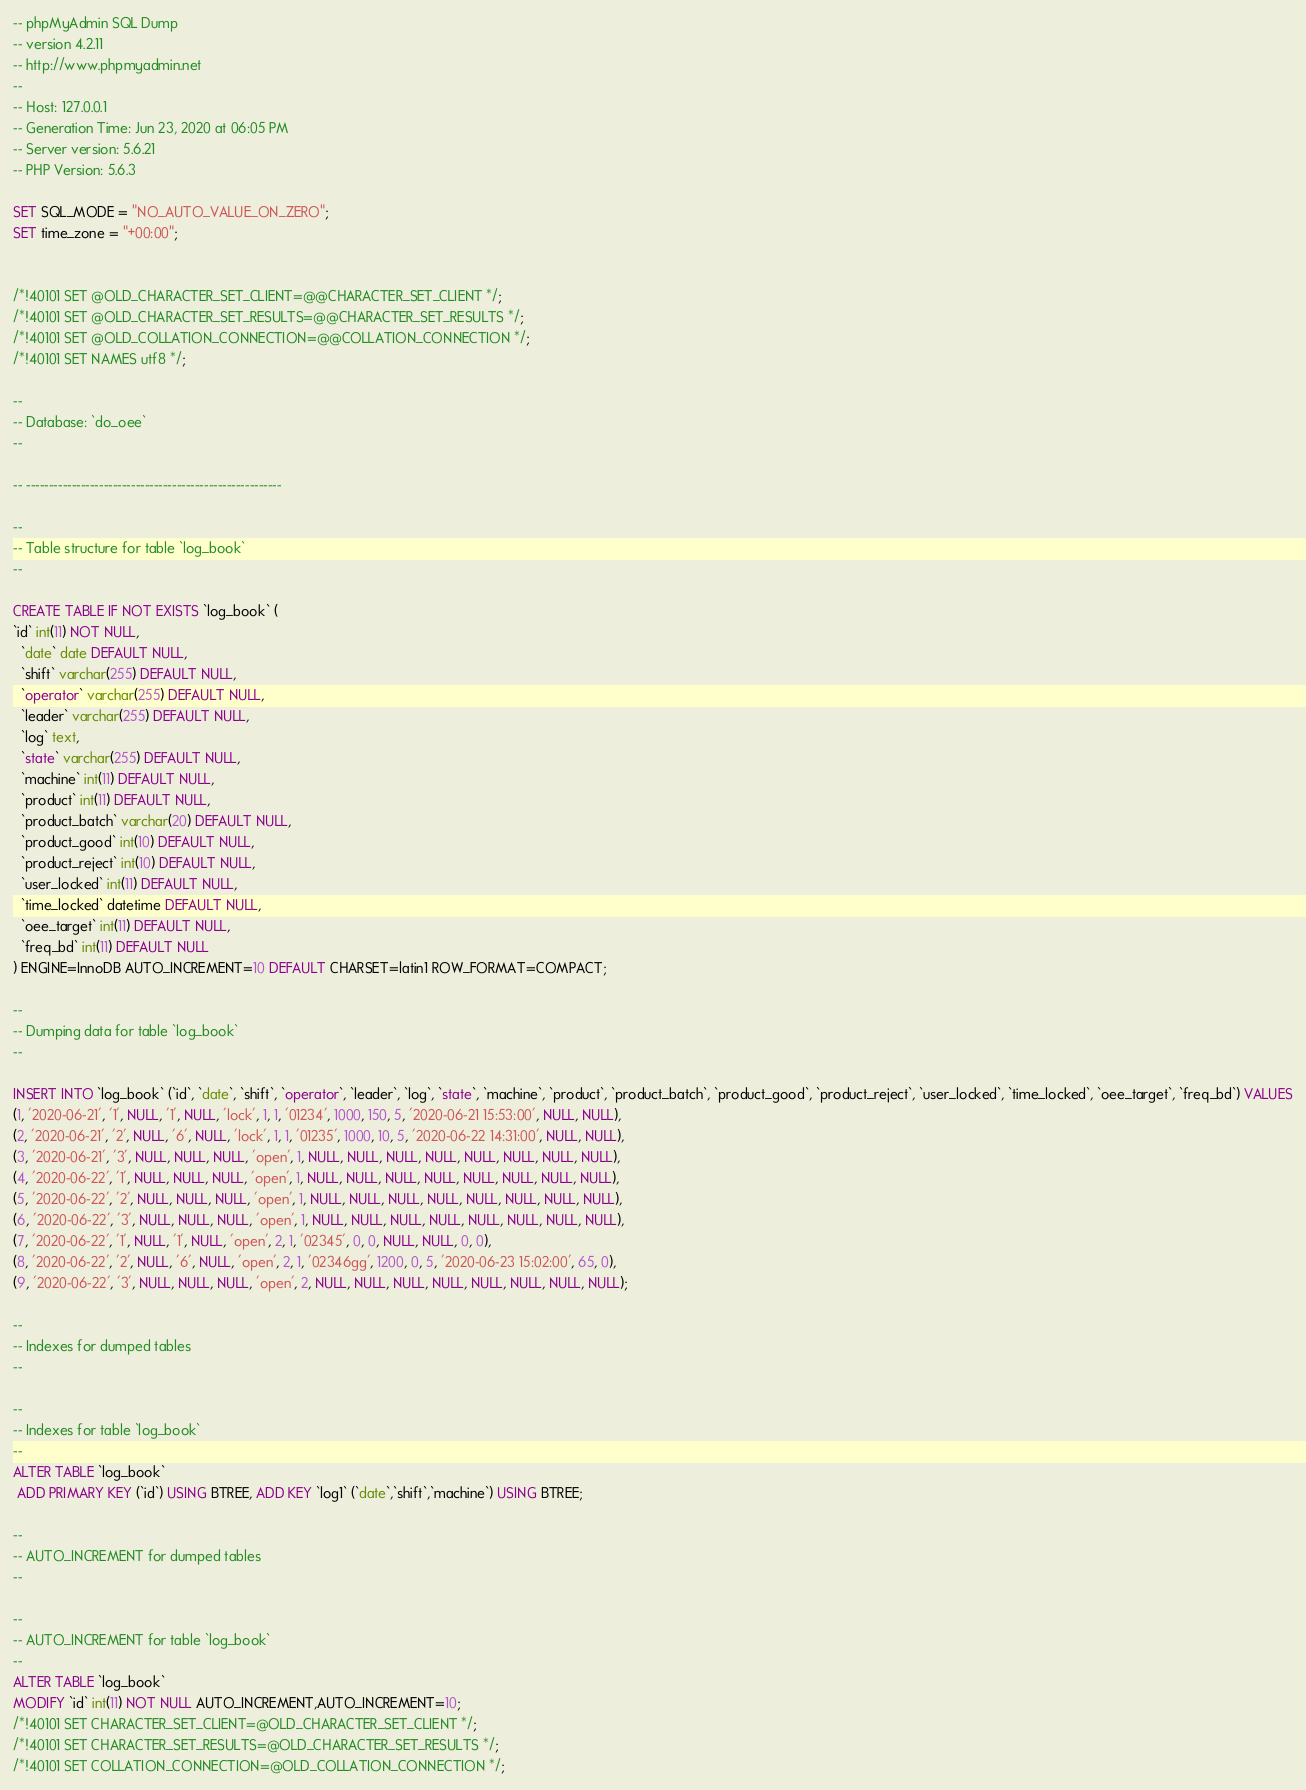Convert code to text. <code><loc_0><loc_0><loc_500><loc_500><_SQL_>-- phpMyAdmin SQL Dump
-- version 4.2.11
-- http://www.phpmyadmin.net
--
-- Host: 127.0.0.1
-- Generation Time: Jun 23, 2020 at 06:05 PM
-- Server version: 5.6.21
-- PHP Version: 5.6.3

SET SQL_MODE = "NO_AUTO_VALUE_ON_ZERO";
SET time_zone = "+00:00";


/*!40101 SET @OLD_CHARACTER_SET_CLIENT=@@CHARACTER_SET_CLIENT */;
/*!40101 SET @OLD_CHARACTER_SET_RESULTS=@@CHARACTER_SET_RESULTS */;
/*!40101 SET @OLD_COLLATION_CONNECTION=@@COLLATION_CONNECTION */;
/*!40101 SET NAMES utf8 */;

--
-- Database: `do_oee`
--

-- --------------------------------------------------------

--
-- Table structure for table `log_book`
--

CREATE TABLE IF NOT EXISTS `log_book` (
`id` int(11) NOT NULL,
  `date` date DEFAULT NULL,
  `shift` varchar(255) DEFAULT NULL,
  `operator` varchar(255) DEFAULT NULL,
  `leader` varchar(255) DEFAULT NULL,
  `log` text,
  `state` varchar(255) DEFAULT NULL,
  `machine` int(11) DEFAULT NULL,
  `product` int(11) DEFAULT NULL,
  `product_batch` varchar(20) DEFAULT NULL,
  `product_good` int(10) DEFAULT NULL,
  `product_reject` int(10) DEFAULT NULL,
  `user_locked` int(11) DEFAULT NULL,
  `time_locked` datetime DEFAULT NULL,
  `oee_target` int(11) DEFAULT NULL,
  `freq_bd` int(11) DEFAULT NULL
) ENGINE=InnoDB AUTO_INCREMENT=10 DEFAULT CHARSET=latin1 ROW_FORMAT=COMPACT;

--
-- Dumping data for table `log_book`
--

INSERT INTO `log_book` (`id`, `date`, `shift`, `operator`, `leader`, `log`, `state`, `machine`, `product`, `product_batch`, `product_good`, `product_reject`, `user_locked`, `time_locked`, `oee_target`, `freq_bd`) VALUES
(1, '2020-06-21', '1', NULL, '1', NULL, 'lock', 1, 1, '01234', 1000, 150, 5, '2020-06-21 15:53:00', NULL, NULL),
(2, '2020-06-21', '2', NULL, '6', NULL, 'lock', 1, 1, '01235', 1000, 10, 5, '2020-06-22 14:31:00', NULL, NULL),
(3, '2020-06-21', '3', NULL, NULL, NULL, 'open', 1, NULL, NULL, NULL, NULL, NULL, NULL, NULL, NULL),
(4, '2020-06-22', '1', NULL, NULL, NULL, 'open', 1, NULL, NULL, NULL, NULL, NULL, NULL, NULL, NULL),
(5, '2020-06-22', '2', NULL, NULL, NULL, 'open', 1, NULL, NULL, NULL, NULL, NULL, NULL, NULL, NULL),
(6, '2020-06-22', '3', NULL, NULL, NULL, 'open', 1, NULL, NULL, NULL, NULL, NULL, NULL, NULL, NULL),
(7, '2020-06-22', '1', NULL, '1', NULL, 'open', 2, 1, '02345', 0, 0, NULL, NULL, 0, 0),
(8, '2020-06-22', '2', NULL, '6', NULL, 'open', 2, 1, '02346gg', 1200, 0, 5, '2020-06-23 15:02:00', 65, 0),
(9, '2020-06-22', '3', NULL, NULL, NULL, 'open', 2, NULL, NULL, NULL, NULL, NULL, NULL, NULL, NULL);

--
-- Indexes for dumped tables
--

--
-- Indexes for table `log_book`
--
ALTER TABLE `log_book`
 ADD PRIMARY KEY (`id`) USING BTREE, ADD KEY `log1` (`date`,`shift`,`machine`) USING BTREE;

--
-- AUTO_INCREMENT for dumped tables
--

--
-- AUTO_INCREMENT for table `log_book`
--
ALTER TABLE `log_book`
MODIFY `id` int(11) NOT NULL AUTO_INCREMENT,AUTO_INCREMENT=10;
/*!40101 SET CHARACTER_SET_CLIENT=@OLD_CHARACTER_SET_CLIENT */;
/*!40101 SET CHARACTER_SET_RESULTS=@OLD_CHARACTER_SET_RESULTS */;
/*!40101 SET COLLATION_CONNECTION=@OLD_COLLATION_CONNECTION */;
</code> 